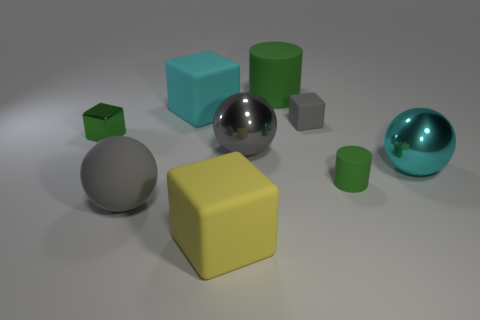Subtract all large gray spheres. How many spheres are left? 1 Subtract all cyan blocks. How many gray spheres are left? 2 Subtract all green cubes. How many cubes are left? 3 Subtract all blocks. How many objects are left? 5 Add 2 large brown matte cubes. How many large brown matte cubes exist? 2 Subtract 0 purple spheres. How many objects are left? 9 Subtract all gray blocks. Subtract all green spheres. How many blocks are left? 3 Subtract all yellow rubber blocks. Subtract all tiny purple matte balls. How many objects are left? 8 Add 6 cyan blocks. How many cyan blocks are left? 7 